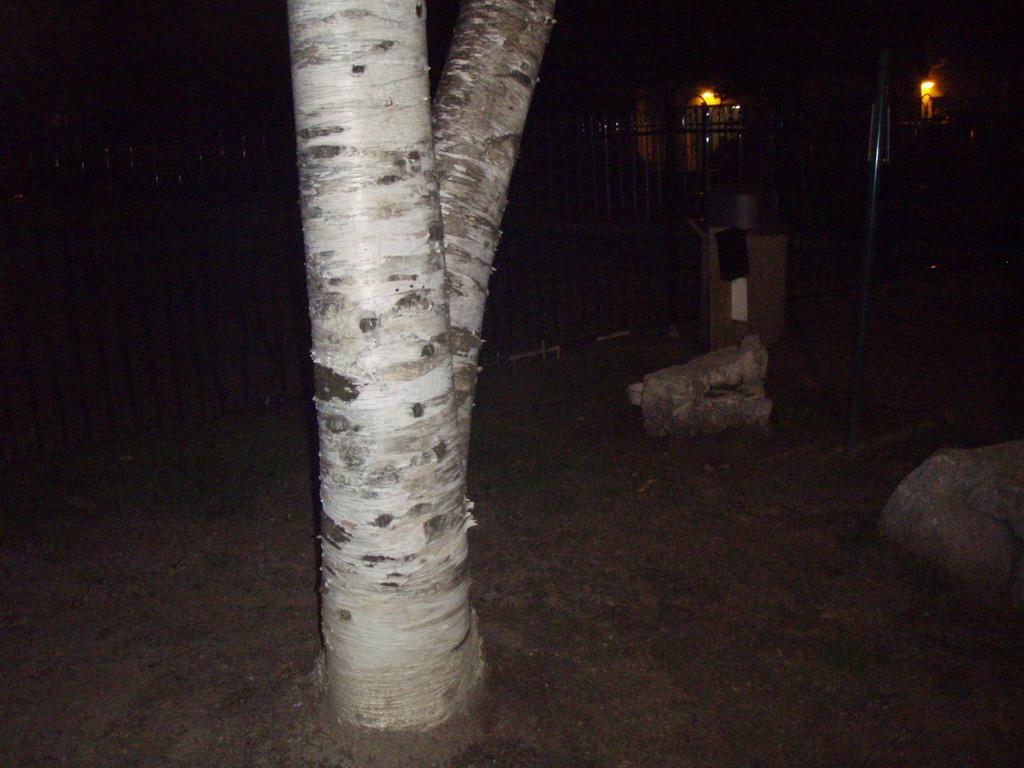Please provide a concise description of this image. In this image I can see a branch,rocks,pole and a fencing. Background is black in color. 